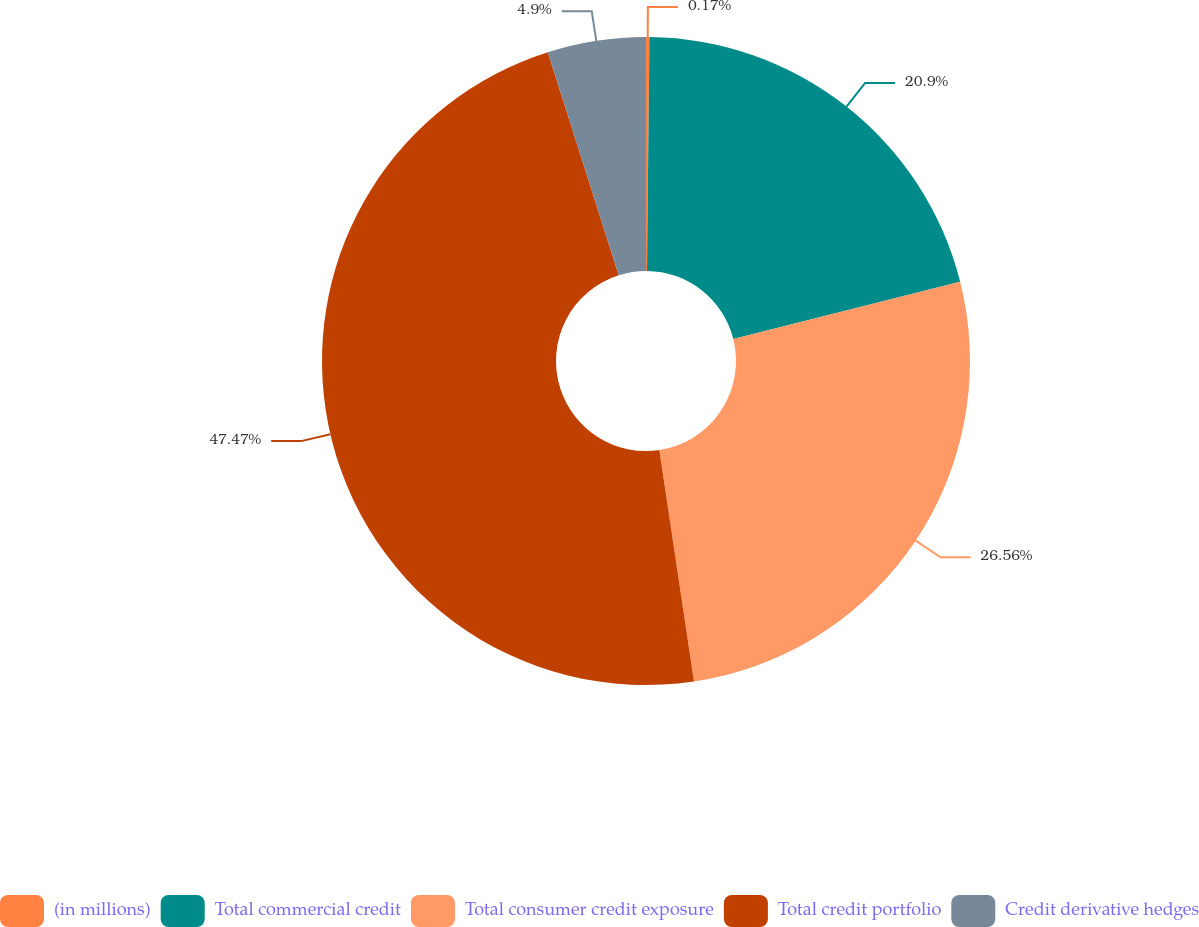Convert chart. <chart><loc_0><loc_0><loc_500><loc_500><pie_chart><fcel>(in millions)<fcel>Total commercial credit<fcel>Total consumer credit exposure<fcel>Total credit portfolio<fcel>Credit derivative hedges<nl><fcel>0.17%<fcel>20.9%<fcel>26.56%<fcel>47.46%<fcel>4.9%<nl></chart> 